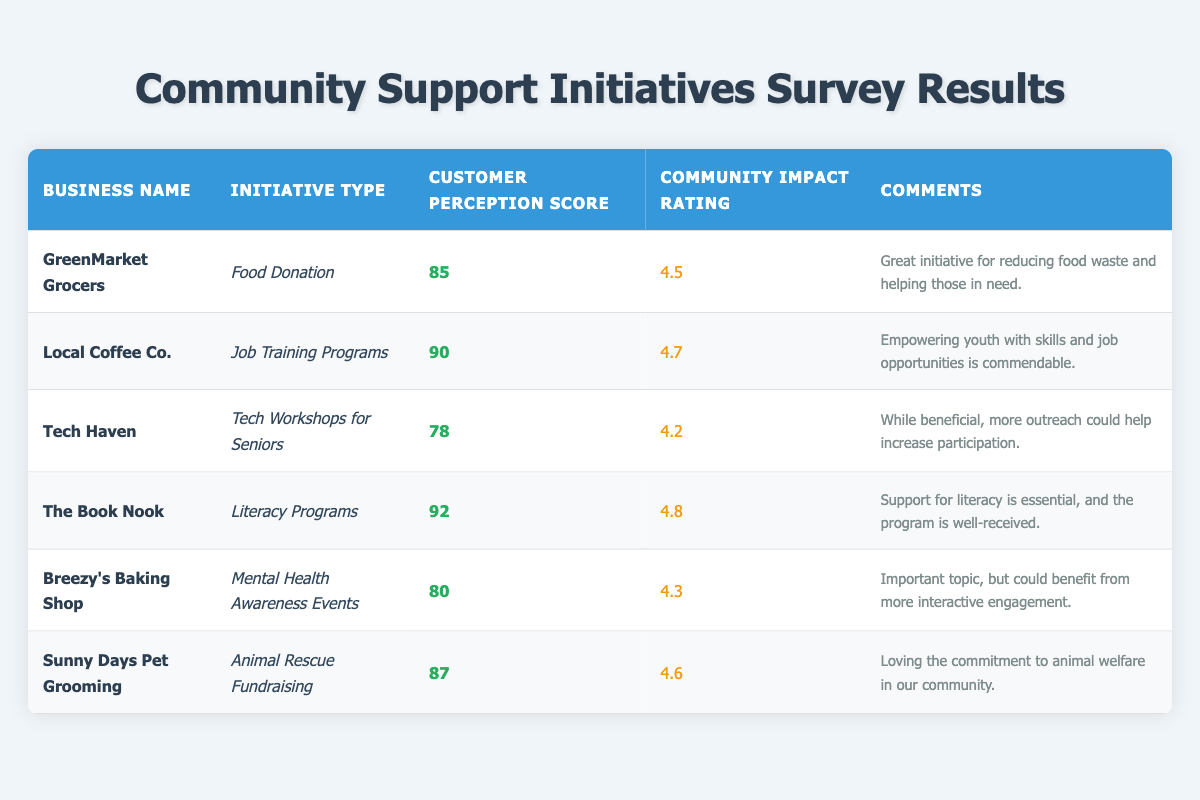What is the customer perception score for Local Coffee Co.? The customer perception score for Local Coffee Co. is directly retrieved from the table in the related row, which states it is 90.
Answer: 90 Which business received the highest community impact rating? The business with the highest community impact rating is The Book Nook, which has a rating of 4.8 according to the table.
Answer: The Book Nook What is the difference between the community impact ratings of Tech Haven and Sunny Days Pet Grooming? To find the difference, I subtract Tech Haven's rating of 4.2 from Sunny Days Pet Grooming's rating of 4.6. Therefore, 4.6 - 4.2 = 0.4.
Answer: 0.4 Did GreenMarket Grocers receive a customer perception score higher than 80? Checking the table, GreenMarket Grocers has a customer perception score of 85, which is indeed higher than 80.
Answer: Yes What is the average customer perception score of all businesses in the survey? First, I add the customer perception scores of all businesses: 85 + 90 + 78 + 92 + 80 + 87 = 512. There are 6 businesses, so the average is 512/6 = 85.33.
Answer: 85.33 Which initiative type has the lowest customer perception score and what is that score? The initiative type with the lowest customer perception score is Tech Workshops for Seniors, which has a score of 78, as stated in the table.
Answer: Tech Workshops for Seniors, 78 If a business is rated at least 4.5 for community impact, how many businesses meet that criterion? From the table, the businesses with a community impact rating of at least 4.5 are Local Coffee Co. (4.7), The Book Nook (4.8), Sunny Days Pet Grooming (4.6), and GreenMarket Grocers (4.5). There are 4 businesses that meet this criterion.
Answer: 4 What percentage of businesses have received a customer perception score above 85? There are 6 businesses total, with Local Coffee Co. (90), The Book Nook (92), and Sunny Days Pet Grooming (87) having scores above 85, which makes 3 businesses. The percentage is (3/6) * 100 = 50%.
Answer: 50% How many comments indicate a need for improvement or further outreach? Checking the comments, only Tech Haven’s comment indicates a need for improvement due to the request for more outreach. Thus, only 1 comment suggests this.
Answer: 1 